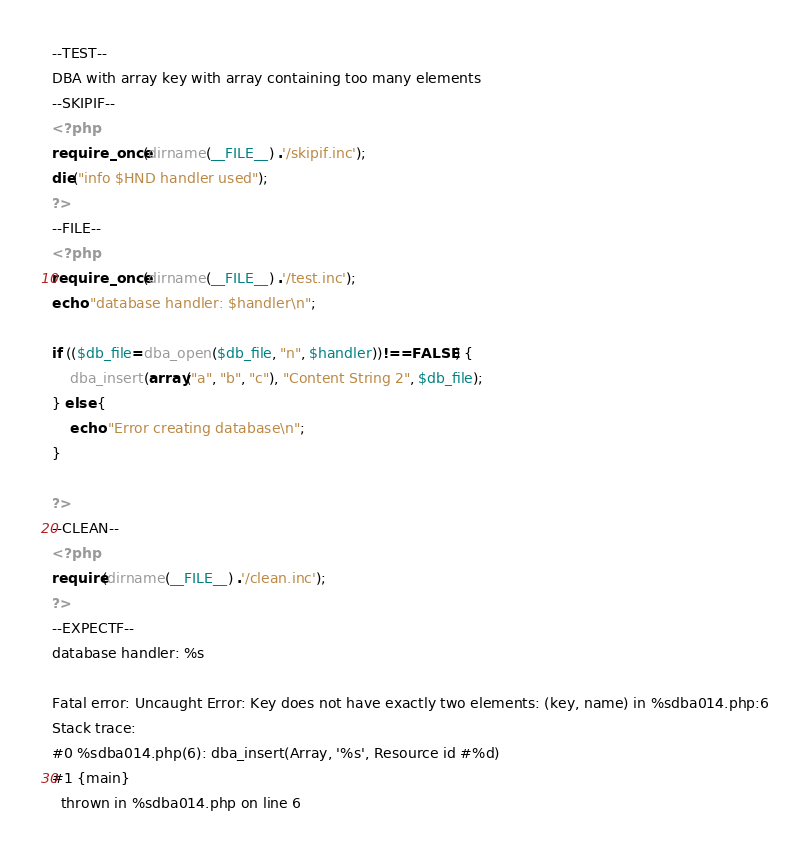Convert code to text. <code><loc_0><loc_0><loc_500><loc_500><_PHP_>--TEST--
DBA with array key with array containing too many elements
--SKIPIF--
<?php
require_once(dirname(__FILE__) .'/skipif.inc');
die("info $HND handler used");
?>
--FILE--
<?php
require_once(dirname(__FILE__) .'/test.inc');
echo "database handler: $handler\n";

if (($db_file=dba_open($db_file, "n", $handler))!==FALSE) {
    dba_insert(array("a", "b", "c"), "Content String 2", $db_file);
} else {
    echo "Error creating database\n";
}

?>
--CLEAN--
<?php
require(dirname(__FILE__) .'/clean.inc');
?>
--EXPECTF--
database handler: %s

Fatal error: Uncaught Error: Key does not have exactly two elements: (key, name) in %sdba014.php:6
Stack trace:
#0 %sdba014.php(6): dba_insert(Array, '%s', Resource id #%d)
#1 {main}
  thrown in %sdba014.php on line 6
</code> 